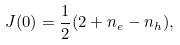Convert formula to latex. <formula><loc_0><loc_0><loc_500><loc_500>J ( 0 ) = \frac { 1 } { 2 } ( 2 + n _ { e } - n _ { h } ) ,</formula> 